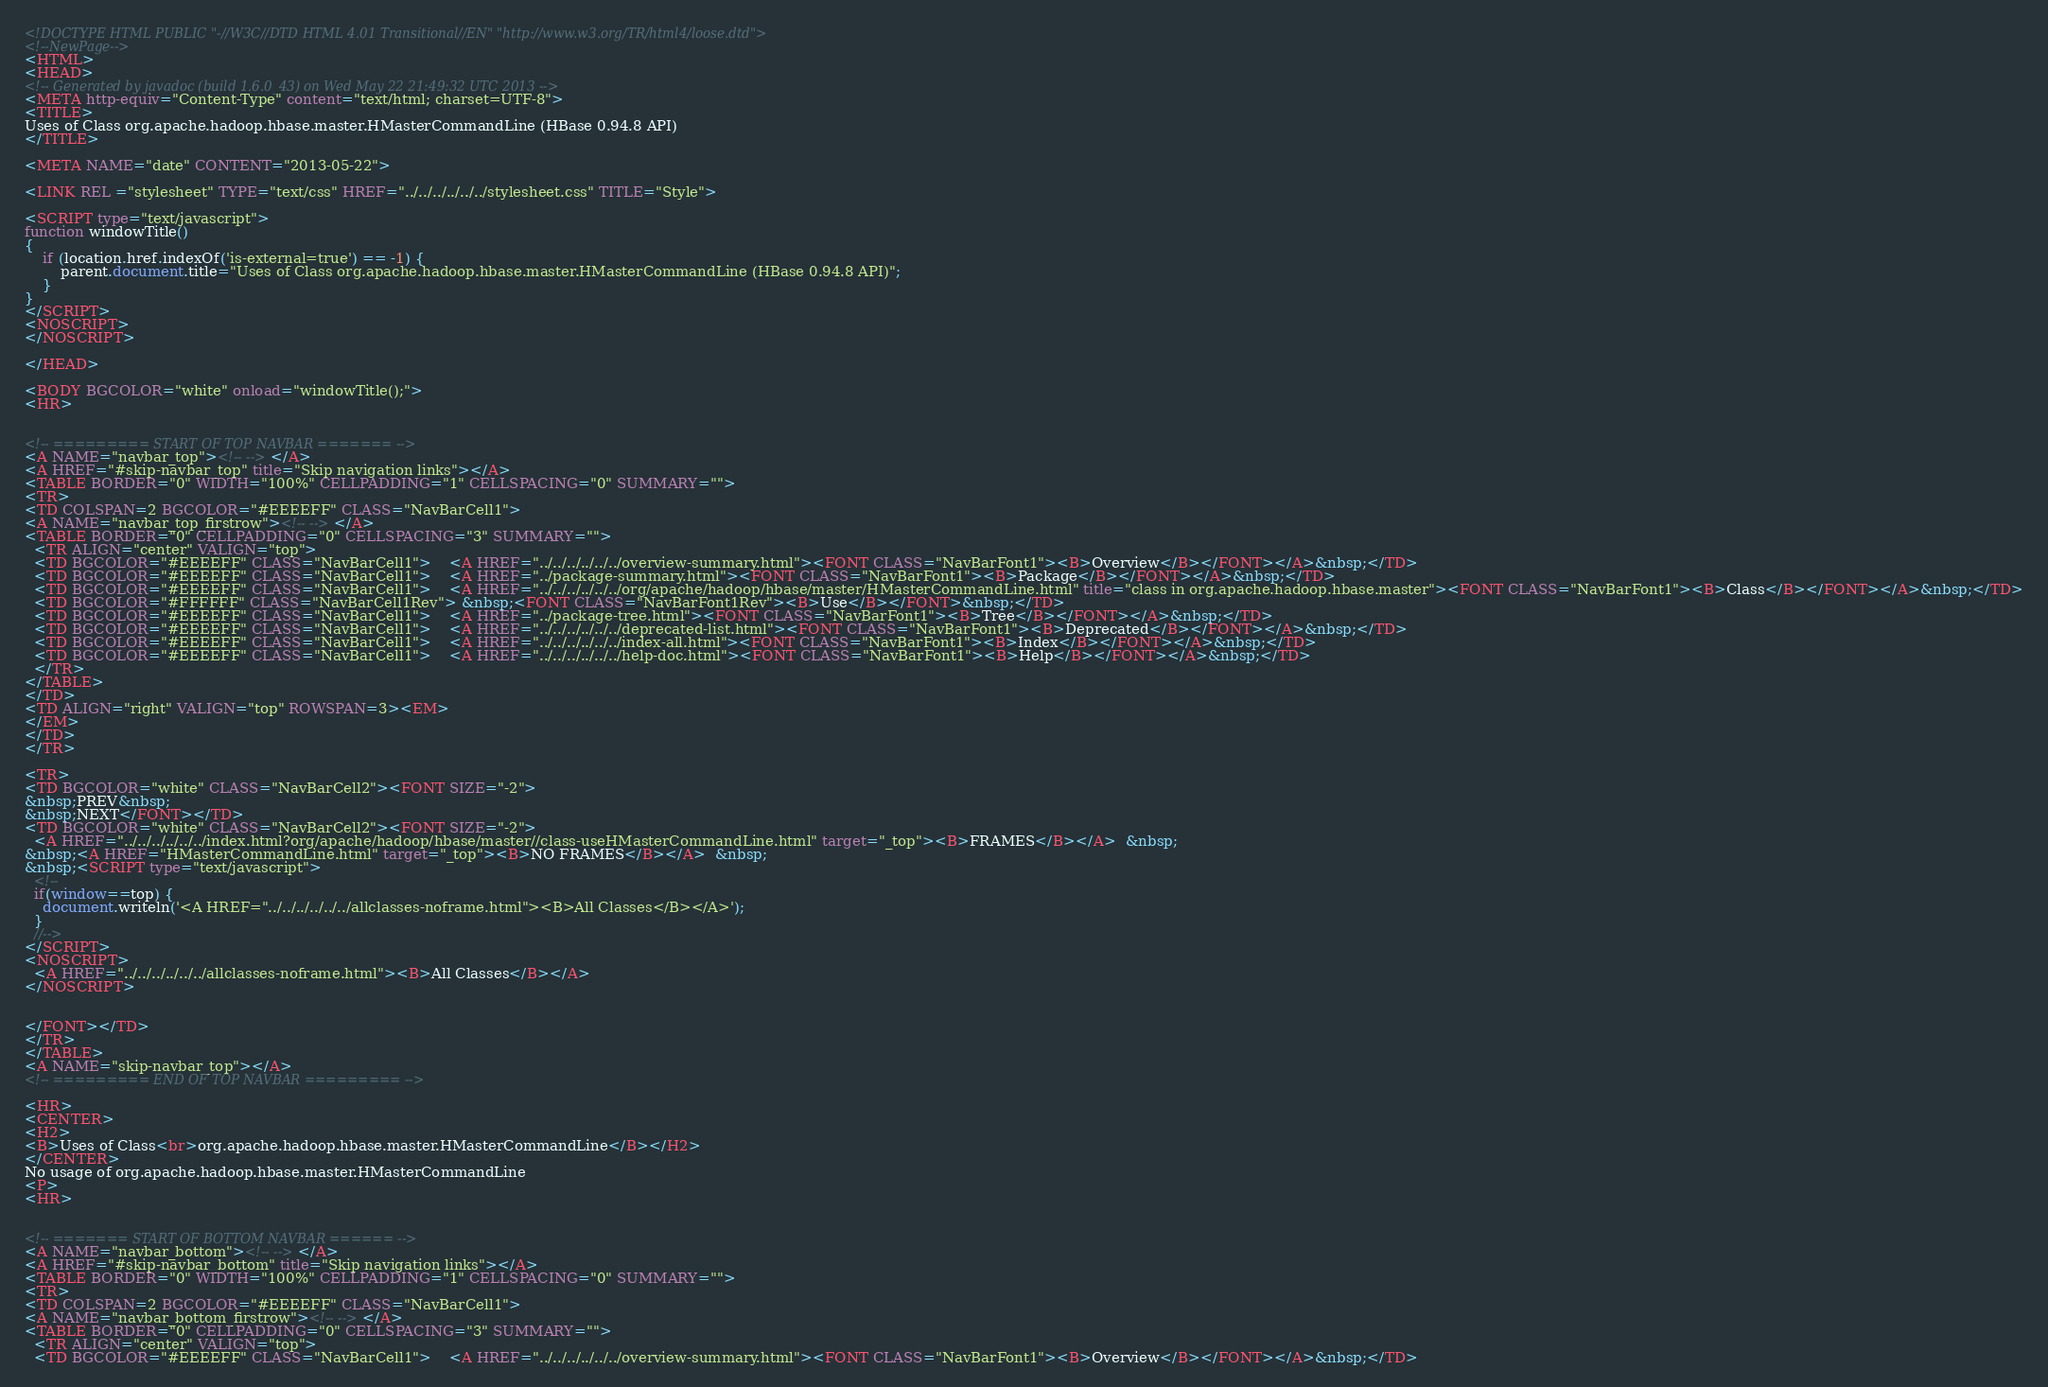Convert code to text. <code><loc_0><loc_0><loc_500><loc_500><_HTML_><!DOCTYPE HTML PUBLIC "-//W3C//DTD HTML 4.01 Transitional//EN" "http://www.w3.org/TR/html4/loose.dtd">
<!--NewPage-->
<HTML>
<HEAD>
<!-- Generated by javadoc (build 1.6.0_43) on Wed May 22 21:49:32 UTC 2013 -->
<META http-equiv="Content-Type" content="text/html; charset=UTF-8">
<TITLE>
Uses of Class org.apache.hadoop.hbase.master.HMasterCommandLine (HBase 0.94.8 API)
</TITLE>

<META NAME="date" CONTENT="2013-05-22">

<LINK REL ="stylesheet" TYPE="text/css" HREF="../../../../../../stylesheet.css" TITLE="Style">

<SCRIPT type="text/javascript">
function windowTitle()
{
    if (location.href.indexOf('is-external=true') == -1) {
        parent.document.title="Uses of Class org.apache.hadoop.hbase.master.HMasterCommandLine (HBase 0.94.8 API)";
    }
}
</SCRIPT>
<NOSCRIPT>
</NOSCRIPT>

</HEAD>

<BODY BGCOLOR="white" onload="windowTitle();">
<HR>


<!-- ========= START OF TOP NAVBAR ======= -->
<A NAME="navbar_top"><!-- --></A>
<A HREF="#skip-navbar_top" title="Skip navigation links"></A>
<TABLE BORDER="0" WIDTH="100%" CELLPADDING="1" CELLSPACING="0" SUMMARY="">
<TR>
<TD COLSPAN=2 BGCOLOR="#EEEEFF" CLASS="NavBarCell1">
<A NAME="navbar_top_firstrow"><!-- --></A>
<TABLE BORDER="0" CELLPADDING="0" CELLSPACING="3" SUMMARY="">
  <TR ALIGN="center" VALIGN="top">
  <TD BGCOLOR="#EEEEFF" CLASS="NavBarCell1">    <A HREF="../../../../../../overview-summary.html"><FONT CLASS="NavBarFont1"><B>Overview</B></FONT></A>&nbsp;</TD>
  <TD BGCOLOR="#EEEEFF" CLASS="NavBarCell1">    <A HREF="../package-summary.html"><FONT CLASS="NavBarFont1"><B>Package</B></FONT></A>&nbsp;</TD>
  <TD BGCOLOR="#EEEEFF" CLASS="NavBarCell1">    <A HREF="../../../../../../org/apache/hadoop/hbase/master/HMasterCommandLine.html" title="class in org.apache.hadoop.hbase.master"><FONT CLASS="NavBarFont1"><B>Class</B></FONT></A>&nbsp;</TD>
  <TD BGCOLOR="#FFFFFF" CLASS="NavBarCell1Rev"> &nbsp;<FONT CLASS="NavBarFont1Rev"><B>Use</B></FONT>&nbsp;</TD>
  <TD BGCOLOR="#EEEEFF" CLASS="NavBarCell1">    <A HREF="../package-tree.html"><FONT CLASS="NavBarFont1"><B>Tree</B></FONT></A>&nbsp;</TD>
  <TD BGCOLOR="#EEEEFF" CLASS="NavBarCell1">    <A HREF="../../../../../../deprecated-list.html"><FONT CLASS="NavBarFont1"><B>Deprecated</B></FONT></A>&nbsp;</TD>
  <TD BGCOLOR="#EEEEFF" CLASS="NavBarCell1">    <A HREF="../../../../../../index-all.html"><FONT CLASS="NavBarFont1"><B>Index</B></FONT></A>&nbsp;</TD>
  <TD BGCOLOR="#EEEEFF" CLASS="NavBarCell1">    <A HREF="../../../../../../help-doc.html"><FONT CLASS="NavBarFont1"><B>Help</B></FONT></A>&nbsp;</TD>
  </TR>
</TABLE>
</TD>
<TD ALIGN="right" VALIGN="top" ROWSPAN=3><EM>
</EM>
</TD>
</TR>

<TR>
<TD BGCOLOR="white" CLASS="NavBarCell2"><FONT SIZE="-2">
&nbsp;PREV&nbsp;
&nbsp;NEXT</FONT></TD>
<TD BGCOLOR="white" CLASS="NavBarCell2"><FONT SIZE="-2">
  <A HREF="../../../../../../index.html?org/apache/hadoop/hbase/master//class-useHMasterCommandLine.html" target="_top"><B>FRAMES</B></A>  &nbsp;
&nbsp;<A HREF="HMasterCommandLine.html" target="_top"><B>NO FRAMES</B></A>  &nbsp;
&nbsp;<SCRIPT type="text/javascript">
  <!--
  if(window==top) {
    document.writeln('<A HREF="../../../../../../allclasses-noframe.html"><B>All Classes</B></A>');
  }
  //-->
</SCRIPT>
<NOSCRIPT>
  <A HREF="../../../../../../allclasses-noframe.html"><B>All Classes</B></A>
</NOSCRIPT>


</FONT></TD>
</TR>
</TABLE>
<A NAME="skip-navbar_top"></A>
<!-- ========= END OF TOP NAVBAR ========= -->

<HR>
<CENTER>
<H2>
<B>Uses of Class<br>org.apache.hadoop.hbase.master.HMasterCommandLine</B></H2>
</CENTER>
No usage of org.apache.hadoop.hbase.master.HMasterCommandLine
<P>
<HR>


<!-- ======= START OF BOTTOM NAVBAR ====== -->
<A NAME="navbar_bottom"><!-- --></A>
<A HREF="#skip-navbar_bottom" title="Skip navigation links"></A>
<TABLE BORDER="0" WIDTH="100%" CELLPADDING="1" CELLSPACING="0" SUMMARY="">
<TR>
<TD COLSPAN=2 BGCOLOR="#EEEEFF" CLASS="NavBarCell1">
<A NAME="navbar_bottom_firstrow"><!-- --></A>
<TABLE BORDER="0" CELLPADDING="0" CELLSPACING="3" SUMMARY="">
  <TR ALIGN="center" VALIGN="top">
  <TD BGCOLOR="#EEEEFF" CLASS="NavBarCell1">    <A HREF="../../../../../../overview-summary.html"><FONT CLASS="NavBarFont1"><B>Overview</B></FONT></A>&nbsp;</TD></code> 